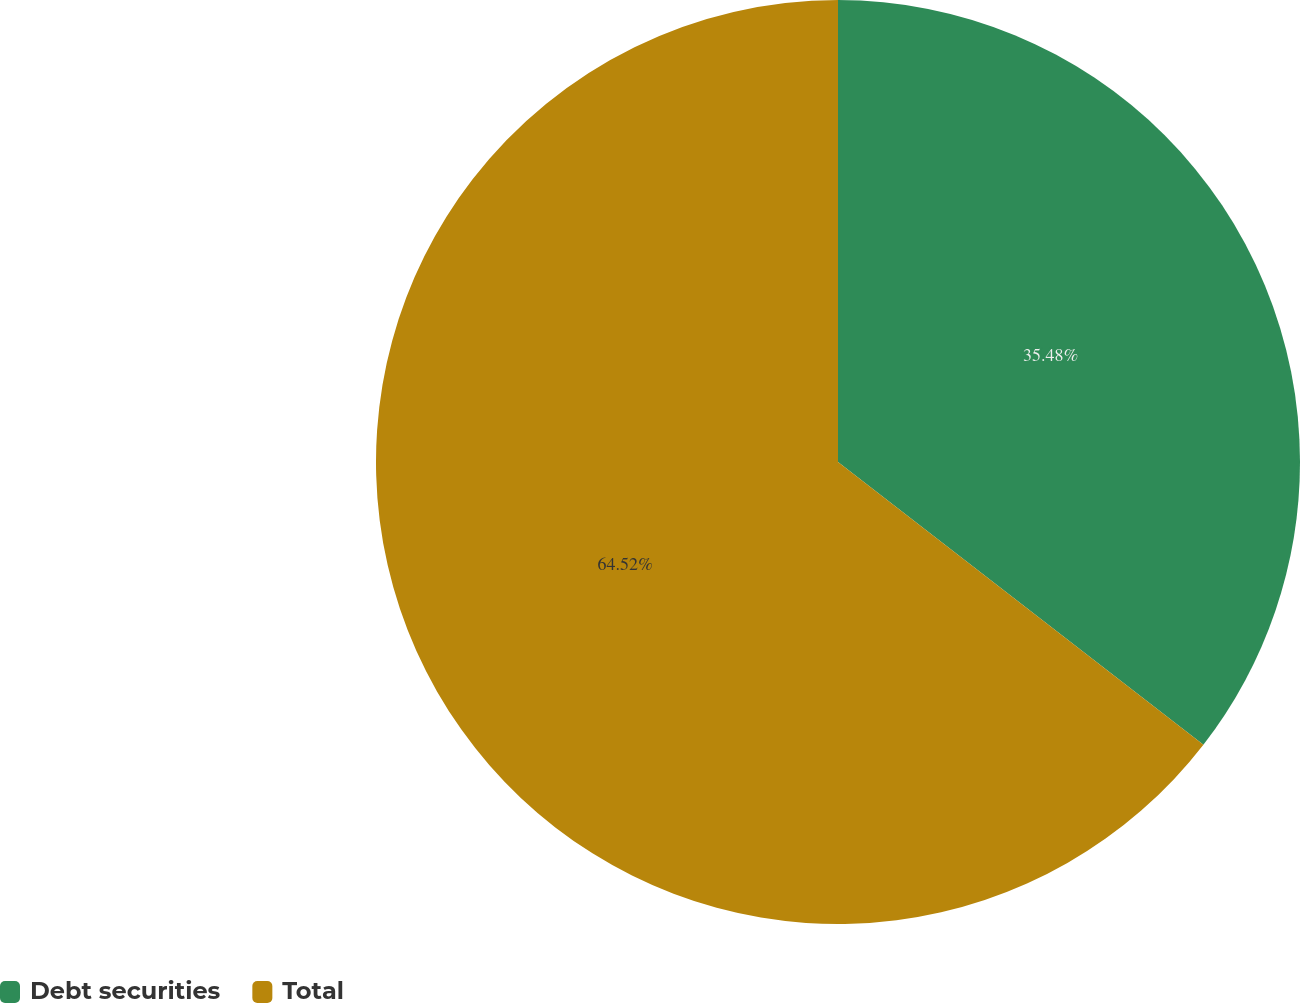Convert chart. <chart><loc_0><loc_0><loc_500><loc_500><pie_chart><fcel>Debt securities<fcel>Total<nl><fcel>35.48%<fcel>64.52%<nl></chart> 